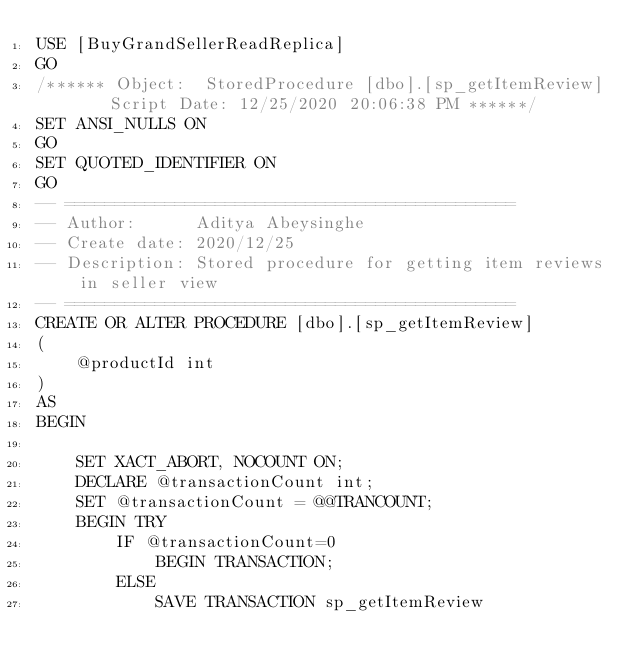Convert code to text. <code><loc_0><loc_0><loc_500><loc_500><_SQL_>USE [BuyGrandSellerReadReplica]
GO
/****** Object:  StoredProcedure [dbo].[sp_getItemReview]    Script Date: 12/25/2020 20:06:38 PM ******/
SET ANSI_NULLS ON
GO
SET QUOTED_IDENTIFIER ON
GO
-- =============================================
-- Author:		Aditya Abeysinghe
-- Create date: 2020/12/25
-- Description:	Stored procedure for getting item reviews in seller view
-- =============================================
CREATE OR ALTER PROCEDURE [dbo].[sp_getItemReview]
(
    @productId int
)
AS
BEGIN

	SET XACT_ABORT, NOCOUNT ON;
	DECLARE @transactionCount int;
	SET @transactionCount = @@TRANCOUNT;
	BEGIN TRY
		IF @transactionCount=0
			BEGIN TRANSACTION;
		ELSE
			SAVE TRANSACTION sp_getItemReview
</code> 